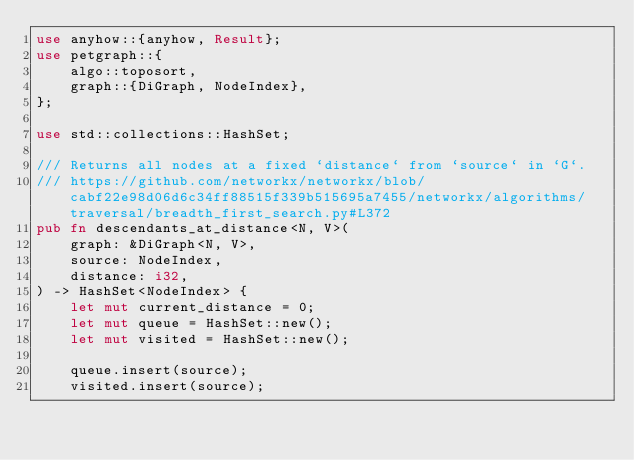<code> <loc_0><loc_0><loc_500><loc_500><_Rust_>use anyhow::{anyhow, Result};
use petgraph::{
    algo::toposort,
    graph::{DiGraph, NodeIndex},
};

use std::collections::HashSet;

/// Returns all nodes at a fixed `distance` from `source` in `G`.
/// https://github.com/networkx/networkx/blob/cabf22e98d06d6c34ff88515f339b515695a7455/networkx/algorithms/traversal/breadth_first_search.py#L372
pub fn descendants_at_distance<N, V>(
    graph: &DiGraph<N, V>,
    source: NodeIndex,
    distance: i32,
) -> HashSet<NodeIndex> {
    let mut current_distance = 0;
    let mut queue = HashSet::new();
    let mut visited = HashSet::new();

    queue.insert(source);
    visited.insert(source);
</code> 